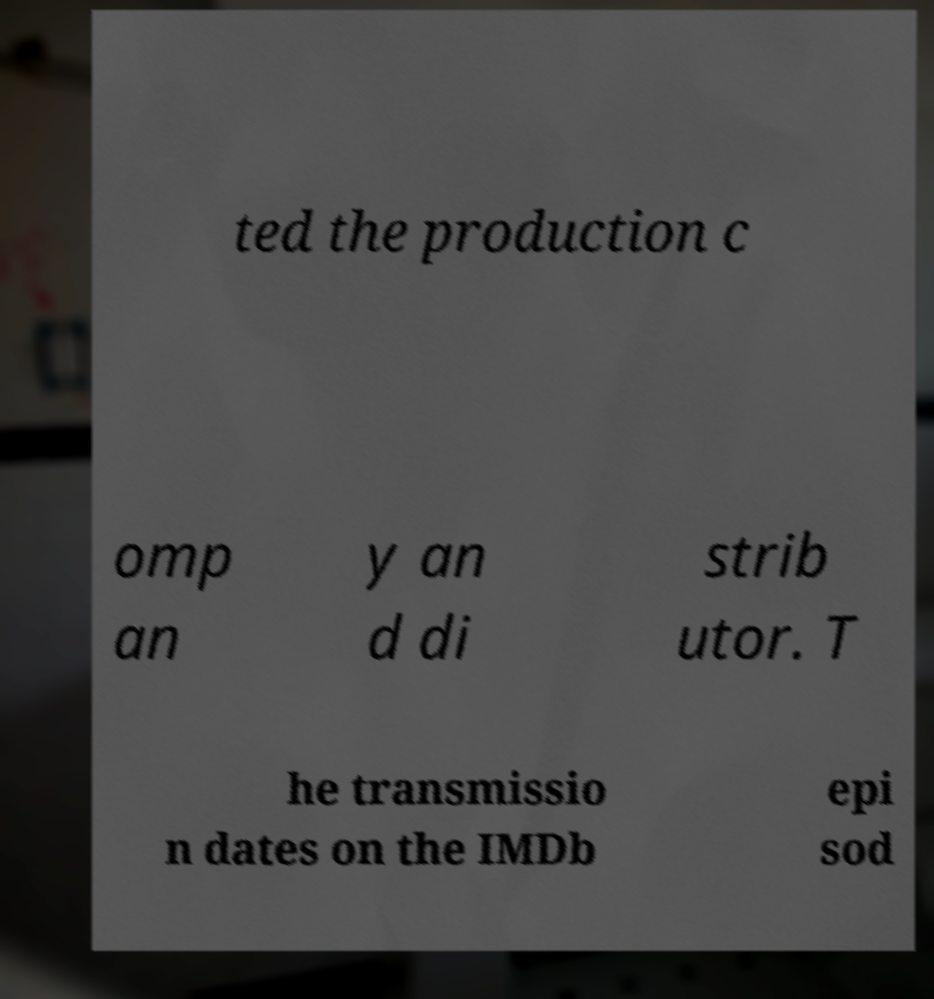I need the written content from this picture converted into text. Can you do that? ted the production c omp an y an d di strib utor. T he transmissio n dates on the IMDb epi sod 